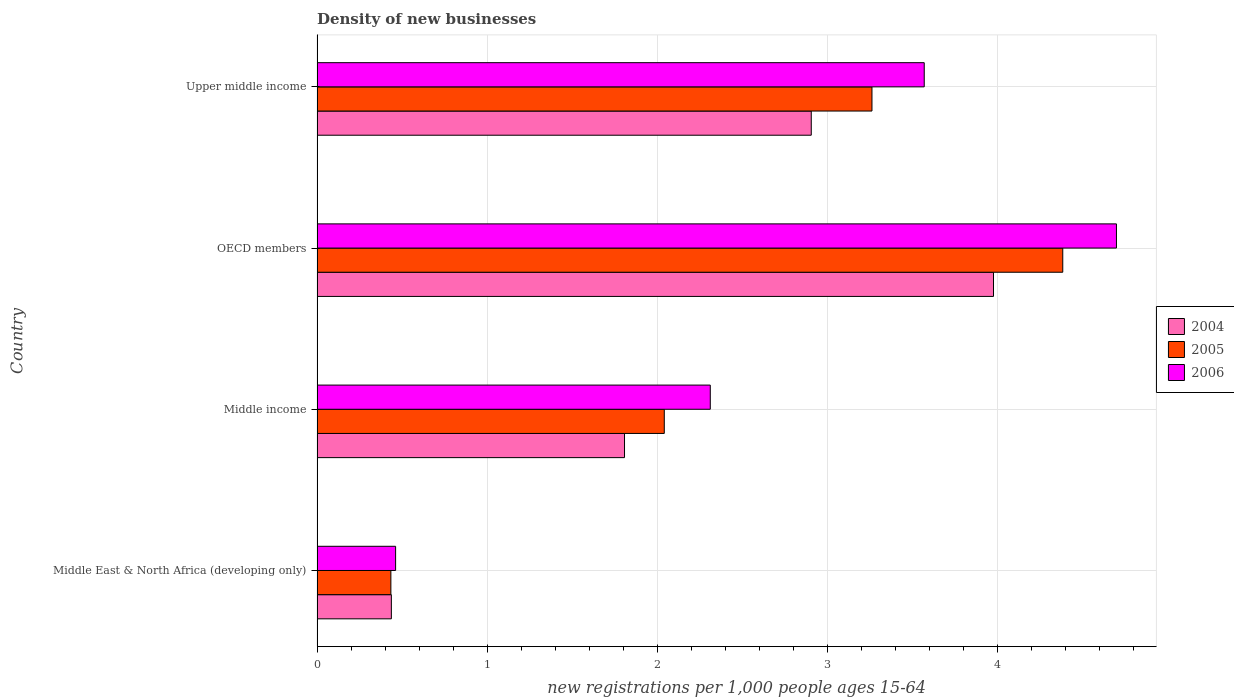How many different coloured bars are there?
Ensure brevity in your answer.  3. Are the number of bars per tick equal to the number of legend labels?
Your response must be concise. Yes. What is the label of the 4th group of bars from the top?
Your response must be concise. Middle East & North Africa (developing only). What is the number of new registrations in 2005 in Upper middle income?
Give a very brief answer. 3.26. Across all countries, what is the maximum number of new registrations in 2006?
Provide a succinct answer. 4.7. Across all countries, what is the minimum number of new registrations in 2004?
Your answer should be compact. 0.44. In which country was the number of new registrations in 2005 minimum?
Make the answer very short. Middle East & North Africa (developing only). What is the total number of new registrations in 2006 in the graph?
Keep it short and to the point. 11.04. What is the difference between the number of new registrations in 2004 in Middle income and that in OECD members?
Provide a succinct answer. -2.17. What is the difference between the number of new registrations in 2004 in Upper middle income and the number of new registrations in 2006 in OECD members?
Your answer should be compact. -1.79. What is the average number of new registrations in 2005 per country?
Your answer should be very brief. 2.53. What is the difference between the number of new registrations in 2004 and number of new registrations in 2006 in Middle income?
Offer a very short reply. -0.5. What is the ratio of the number of new registrations in 2004 in OECD members to that in Upper middle income?
Offer a terse response. 1.37. Is the difference between the number of new registrations in 2004 in Middle East & North Africa (developing only) and OECD members greater than the difference between the number of new registrations in 2006 in Middle East & North Africa (developing only) and OECD members?
Your response must be concise. Yes. What is the difference between the highest and the second highest number of new registrations in 2005?
Ensure brevity in your answer.  1.12. What is the difference between the highest and the lowest number of new registrations in 2006?
Provide a short and direct response. 4.24. In how many countries, is the number of new registrations in 2004 greater than the average number of new registrations in 2004 taken over all countries?
Your answer should be compact. 2. Is the sum of the number of new registrations in 2006 in Middle income and Upper middle income greater than the maximum number of new registrations in 2005 across all countries?
Give a very brief answer. Yes. What does the 1st bar from the bottom in Middle East & North Africa (developing only) represents?
Keep it short and to the point. 2004. Is it the case that in every country, the sum of the number of new registrations in 2005 and number of new registrations in 2004 is greater than the number of new registrations in 2006?
Your response must be concise. Yes. How many bars are there?
Offer a terse response. 12. How many countries are there in the graph?
Offer a terse response. 4. What is the difference between two consecutive major ticks on the X-axis?
Make the answer very short. 1. Does the graph contain any zero values?
Provide a succinct answer. No. Does the graph contain grids?
Ensure brevity in your answer.  Yes. How are the legend labels stacked?
Ensure brevity in your answer.  Vertical. What is the title of the graph?
Make the answer very short. Density of new businesses. What is the label or title of the X-axis?
Give a very brief answer. New registrations per 1,0 people ages 15-64. What is the label or title of the Y-axis?
Your response must be concise. Country. What is the new registrations per 1,000 people ages 15-64 of 2004 in Middle East & North Africa (developing only)?
Provide a succinct answer. 0.44. What is the new registrations per 1,000 people ages 15-64 in 2005 in Middle East & North Africa (developing only)?
Your response must be concise. 0.43. What is the new registrations per 1,000 people ages 15-64 in 2006 in Middle East & North Africa (developing only)?
Make the answer very short. 0.46. What is the new registrations per 1,000 people ages 15-64 in 2004 in Middle income?
Make the answer very short. 1.81. What is the new registrations per 1,000 people ages 15-64 in 2005 in Middle income?
Your answer should be very brief. 2.04. What is the new registrations per 1,000 people ages 15-64 of 2006 in Middle income?
Your answer should be compact. 2.31. What is the new registrations per 1,000 people ages 15-64 in 2004 in OECD members?
Your answer should be compact. 3.98. What is the new registrations per 1,000 people ages 15-64 in 2005 in OECD members?
Offer a very short reply. 4.38. What is the new registrations per 1,000 people ages 15-64 in 2006 in OECD members?
Provide a short and direct response. 4.7. What is the new registrations per 1,000 people ages 15-64 in 2004 in Upper middle income?
Offer a terse response. 2.9. What is the new registrations per 1,000 people ages 15-64 of 2005 in Upper middle income?
Offer a very short reply. 3.26. What is the new registrations per 1,000 people ages 15-64 of 2006 in Upper middle income?
Provide a short and direct response. 3.57. Across all countries, what is the maximum new registrations per 1,000 people ages 15-64 of 2004?
Provide a succinct answer. 3.98. Across all countries, what is the maximum new registrations per 1,000 people ages 15-64 in 2005?
Keep it short and to the point. 4.38. Across all countries, what is the maximum new registrations per 1,000 people ages 15-64 in 2006?
Your response must be concise. 4.7. Across all countries, what is the minimum new registrations per 1,000 people ages 15-64 of 2004?
Provide a short and direct response. 0.44. Across all countries, what is the minimum new registrations per 1,000 people ages 15-64 of 2005?
Make the answer very short. 0.43. Across all countries, what is the minimum new registrations per 1,000 people ages 15-64 of 2006?
Provide a short and direct response. 0.46. What is the total new registrations per 1,000 people ages 15-64 of 2004 in the graph?
Your answer should be compact. 9.12. What is the total new registrations per 1,000 people ages 15-64 of 2005 in the graph?
Provide a succinct answer. 10.12. What is the total new registrations per 1,000 people ages 15-64 of 2006 in the graph?
Keep it short and to the point. 11.04. What is the difference between the new registrations per 1,000 people ages 15-64 of 2004 in Middle East & North Africa (developing only) and that in Middle income?
Give a very brief answer. -1.37. What is the difference between the new registrations per 1,000 people ages 15-64 in 2005 in Middle East & North Africa (developing only) and that in Middle income?
Ensure brevity in your answer.  -1.61. What is the difference between the new registrations per 1,000 people ages 15-64 in 2006 in Middle East & North Africa (developing only) and that in Middle income?
Ensure brevity in your answer.  -1.85. What is the difference between the new registrations per 1,000 people ages 15-64 in 2004 in Middle East & North Africa (developing only) and that in OECD members?
Provide a short and direct response. -3.54. What is the difference between the new registrations per 1,000 people ages 15-64 of 2005 in Middle East & North Africa (developing only) and that in OECD members?
Your answer should be very brief. -3.95. What is the difference between the new registrations per 1,000 people ages 15-64 of 2006 in Middle East & North Africa (developing only) and that in OECD members?
Keep it short and to the point. -4.24. What is the difference between the new registrations per 1,000 people ages 15-64 of 2004 in Middle East & North Africa (developing only) and that in Upper middle income?
Offer a very short reply. -2.47. What is the difference between the new registrations per 1,000 people ages 15-64 of 2005 in Middle East & North Africa (developing only) and that in Upper middle income?
Ensure brevity in your answer.  -2.83. What is the difference between the new registrations per 1,000 people ages 15-64 of 2006 in Middle East & North Africa (developing only) and that in Upper middle income?
Provide a short and direct response. -3.11. What is the difference between the new registrations per 1,000 people ages 15-64 in 2004 in Middle income and that in OECD members?
Your response must be concise. -2.17. What is the difference between the new registrations per 1,000 people ages 15-64 of 2005 in Middle income and that in OECD members?
Keep it short and to the point. -2.34. What is the difference between the new registrations per 1,000 people ages 15-64 in 2006 in Middle income and that in OECD members?
Provide a succinct answer. -2.39. What is the difference between the new registrations per 1,000 people ages 15-64 in 2004 in Middle income and that in Upper middle income?
Your response must be concise. -1.1. What is the difference between the new registrations per 1,000 people ages 15-64 in 2005 in Middle income and that in Upper middle income?
Your response must be concise. -1.22. What is the difference between the new registrations per 1,000 people ages 15-64 in 2006 in Middle income and that in Upper middle income?
Provide a succinct answer. -1.26. What is the difference between the new registrations per 1,000 people ages 15-64 in 2004 in OECD members and that in Upper middle income?
Provide a short and direct response. 1.07. What is the difference between the new registrations per 1,000 people ages 15-64 in 2005 in OECD members and that in Upper middle income?
Give a very brief answer. 1.12. What is the difference between the new registrations per 1,000 people ages 15-64 in 2006 in OECD members and that in Upper middle income?
Give a very brief answer. 1.13. What is the difference between the new registrations per 1,000 people ages 15-64 of 2004 in Middle East & North Africa (developing only) and the new registrations per 1,000 people ages 15-64 of 2005 in Middle income?
Ensure brevity in your answer.  -1.6. What is the difference between the new registrations per 1,000 people ages 15-64 in 2004 in Middle East & North Africa (developing only) and the new registrations per 1,000 people ages 15-64 in 2006 in Middle income?
Ensure brevity in your answer.  -1.87. What is the difference between the new registrations per 1,000 people ages 15-64 of 2005 in Middle East & North Africa (developing only) and the new registrations per 1,000 people ages 15-64 of 2006 in Middle income?
Ensure brevity in your answer.  -1.88. What is the difference between the new registrations per 1,000 people ages 15-64 in 2004 in Middle East & North Africa (developing only) and the new registrations per 1,000 people ages 15-64 in 2005 in OECD members?
Your answer should be compact. -3.95. What is the difference between the new registrations per 1,000 people ages 15-64 of 2004 in Middle East & North Africa (developing only) and the new registrations per 1,000 people ages 15-64 of 2006 in OECD members?
Offer a very short reply. -4.26. What is the difference between the new registrations per 1,000 people ages 15-64 in 2005 in Middle East & North Africa (developing only) and the new registrations per 1,000 people ages 15-64 in 2006 in OECD members?
Your answer should be very brief. -4.26. What is the difference between the new registrations per 1,000 people ages 15-64 in 2004 in Middle East & North Africa (developing only) and the new registrations per 1,000 people ages 15-64 in 2005 in Upper middle income?
Offer a very short reply. -2.82. What is the difference between the new registrations per 1,000 people ages 15-64 of 2004 in Middle East & North Africa (developing only) and the new registrations per 1,000 people ages 15-64 of 2006 in Upper middle income?
Offer a terse response. -3.13. What is the difference between the new registrations per 1,000 people ages 15-64 of 2005 in Middle East & North Africa (developing only) and the new registrations per 1,000 people ages 15-64 of 2006 in Upper middle income?
Provide a succinct answer. -3.13. What is the difference between the new registrations per 1,000 people ages 15-64 in 2004 in Middle income and the new registrations per 1,000 people ages 15-64 in 2005 in OECD members?
Offer a terse response. -2.58. What is the difference between the new registrations per 1,000 people ages 15-64 of 2004 in Middle income and the new registrations per 1,000 people ages 15-64 of 2006 in OECD members?
Give a very brief answer. -2.89. What is the difference between the new registrations per 1,000 people ages 15-64 of 2005 in Middle income and the new registrations per 1,000 people ages 15-64 of 2006 in OECD members?
Give a very brief answer. -2.66. What is the difference between the new registrations per 1,000 people ages 15-64 in 2004 in Middle income and the new registrations per 1,000 people ages 15-64 in 2005 in Upper middle income?
Offer a very short reply. -1.45. What is the difference between the new registrations per 1,000 people ages 15-64 of 2004 in Middle income and the new registrations per 1,000 people ages 15-64 of 2006 in Upper middle income?
Your answer should be compact. -1.76. What is the difference between the new registrations per 1,000 people ages 15-64 of 2005 in Middle income and the new registrations per 1,000 people ages 15-64 of 2006 in Upper middle income?
Provide a succinct answer. -1.53. What is the difference between the new registrations per 1,000 people ages 15-64 in 2004 in OECD members and the new registrations per 1,000 people ages 15-64 in 2006 in Upper middle income?
Make the answer very short. 0.41. What is the difference between the new registrations per 1,000 people ages 15-64 in 2005 in OECD members and the new registrations per 1,000 people ages 15-64 in 2006 in Upper middle income?
Give a very brief answer. 0.81. What is the average new registrations per 1,000 people ages 15-64 of 2004 per country?
Offer a terse response. 2.28. What is the average new registrations per 1,000 people ages 15-64 of 2005 per country?
Your answer should be very brief. 2.53. What is the average new registrations per 1,000 people ages 15-64 of 2006 per country?
Provide a short and direct response. 2.76. What is the difference between the new registrations per 1,000 people ages 15-64 in 2004 and new registrations per 1,000 people ages 15-64 in 2005 in Middle East & North Africa (developing only)?
Keep it short and to the point. 0. What is the difference between the new registrations per 1,000 people ages 15-64 of 2004 and new registrations per 1,000 people ages 15-64 of 2006 in Middle East & North Africa (developing only)?
Give a very brief answer. -0.02. What is the difference between the new registrations per 1,000 people ages 15-64 of 2005 and new registrations per 1,000 people ages 15-64 of 2006 in Middle East & North Africa (developing only)?
Provide a succinct answer. -0.03. What is the difference between the new registrations per 1,000 people ages 15-64 in 2004 and new registrations per 1,000 people ages 15-64 in 2005 in Middle income?
Provide a short and direct response. -0.23. What is the difference between the new registrations per 1,000 people ages 15-64 in 2004 and new registrations per 1,000 people ages 15-64 in 2006 in Middle income?
Provide a succinct answer. -0.5. What is the difference between the new registrations per 1,000 people ages 15-64 of 2005 and new registrations per 1,000 people ages 15-64 of 2006 in Middle income?
Give a very brief answer. -0.27. What is the difference between the new registrations per 1,000 people ages 15-64 of 2004 and new registrations per 1,000 people ages 15-64 of 2005 in OECD members?
Make the answer very short. -0.41. What is the difference between the new registrations per 1,000 people ages 15-64 in 2004 and new registrations per 1,000 people ages 15-64 in 2006 in OECD members?
Your response must be concise. -0.72. What is the difference between the new registrations per 1,000 people ages 15-64 in 2005 and new registrations per 1,000 people ages 15-64 in 2006 in OECD members?
Ensure brevity in your answer.  -0.32. What is the difference between the new registrations per 1,000 people ages 15-64 of 2004 and new registrations per 1,000 people ages 15-64 of 2005 in Upper middle income?
Ensure brevity in your answer.  -0.36. What is the difference between the new registrations per 1,000 people ages 15-64 of 2004 and new registrations per 1,000 people ages 15-64 of 2006 in Upper middle income?
Make the answer very short. -0.66. What is the difference between the new registrations per 1,000 people ages 15-64 in 2005 and new registrations per 1,000 people ages 15-64 in 2006 in Upper middle income?
Your response must be concise. -0.31. What is the ratio of the new registrations per 1,000 people ages 15-64 in 2004 in Middle East & North Africa (developing only) to that in Middle income?
Offer a terse response. 0.24. What is the ratio of the new registrations per 1,000 people ages 15-64 in 2005 in Middle East & North Africa (developing only) to that in Middle income?
Your answer should be very brief. 0.21. What is the ratio of the new registrations per 1,000 people ages 15-64 in 2006 in Middle East & North Africa (developing only) to that in Middle income?
Your response must be concise. 0.2. What is the ratio of the new registrations per 1,000 people ages 15-64 of 2004 in Middle East & North Africa (developing only) to that in OECD members?
Ensure brevity in your answer.  0.11. What is the ratio of the new registrations per 1,000 people ages 15-64 of 2005 in Middle East & North Africa (developing only) to that in OECD members?
Keep it short and to the point. 0.1. What is the ratio of the new registrations per 1,000 people ages 15-64 in 2006 in Middle East & North Africa (developing only) to that in OECD members?
Keep it short and to the point. 0.1. What is the ratio of the new registrations per 1,000 people ages 15-64 of 2004 in Middle East & North Africa (developing only) to that in Upper middle income?
Offer a terse response. 0.15. What is the ratio of the new registrations per 1,000 people ages 15-64 in 2005 in Middle East & North Africa (developing only) to that in Upper middle income?
Provide a succinct answer. 0.13. What is the ratio of the new registrations per 1,000 people ages 15-64 of 2006 in Middle East & North Africa (developing only) to that in Upper middle income?
Your answer should be very brief. 0.13. What is the ratio of the new registrations per 1,000 people ages 15-64 of 2004 in Middle income to that in OECD members?
Your answer should be very brief. 0.45. What is the ratio of the new registrations per 1,000 people ages 15-64 of 2005 in Middle income to that in OECD members?
Provide a short and direct response. 0.47. What is the ratio of the new registrations per 1,000 people ages 15-64 in 2006 in Middle income to that in OECD members?
Give a very brief answer. 0.49. What is the ratio of the new registrations per 1,000 people ages 15-64 in 2004 in Middle income to that in Upper middle income?
Provide a succinct answer. 0.62. What is the ratio of the new registrations per 1,000 people ages 15-64 in 2005 in Middle income to that in Upper middle income?
Offer a very short reply. 0.63. What is the ratio of the new registrations per 1,000 people ages 15-64 in 2006 in Middle income to that in Upper middle income?
Provide a short and direct response. 0.65. What is the ratio of the new registrations per 1,000 people ages 15-64 of 2004 in OECD members to that in Upper middle income?
Your response must be concise. 1.37. What is the ratio of the new registrations per 1,000 people ages 15-64 in 2005 in OECD members to that in Upper middle income?
Keep it short and to the point. 1.34. What is the ratio of the new registrations per 1,000 people ages 15-64 of 2006 in OECD members to that in Upper middle income?
Your response must be concise. 1.32. What is the difference between the highest and the second highest new registrations per 1,000 people ages 15-64 of 2004?
Your answer should be very brief. 1.07. What is the difference between the highest and the second highest new registrations per 1,000 people ages 15-64 of 2005?
Provide a succinct answer. 1.12. What is the difference between the highest and the second highest new registrations per 1,000 people ages 15-64 of 2006?
Make the answer very short. 1.13. What is the difference between the highest and the lowest new registrations per 1,000 people ages 15-64 in 2004?
Offer a terse response. 3.54. What is the difference between the highest and the lowest new registrations per 1,000 people ages 15-64 in 2005?
Ensure brevity in your answer.  3.95. What is the difference between the highest and the lowest new registrations per 1,000 people ages 15-64 of 2006?
Offer a terse response. 4.24. 